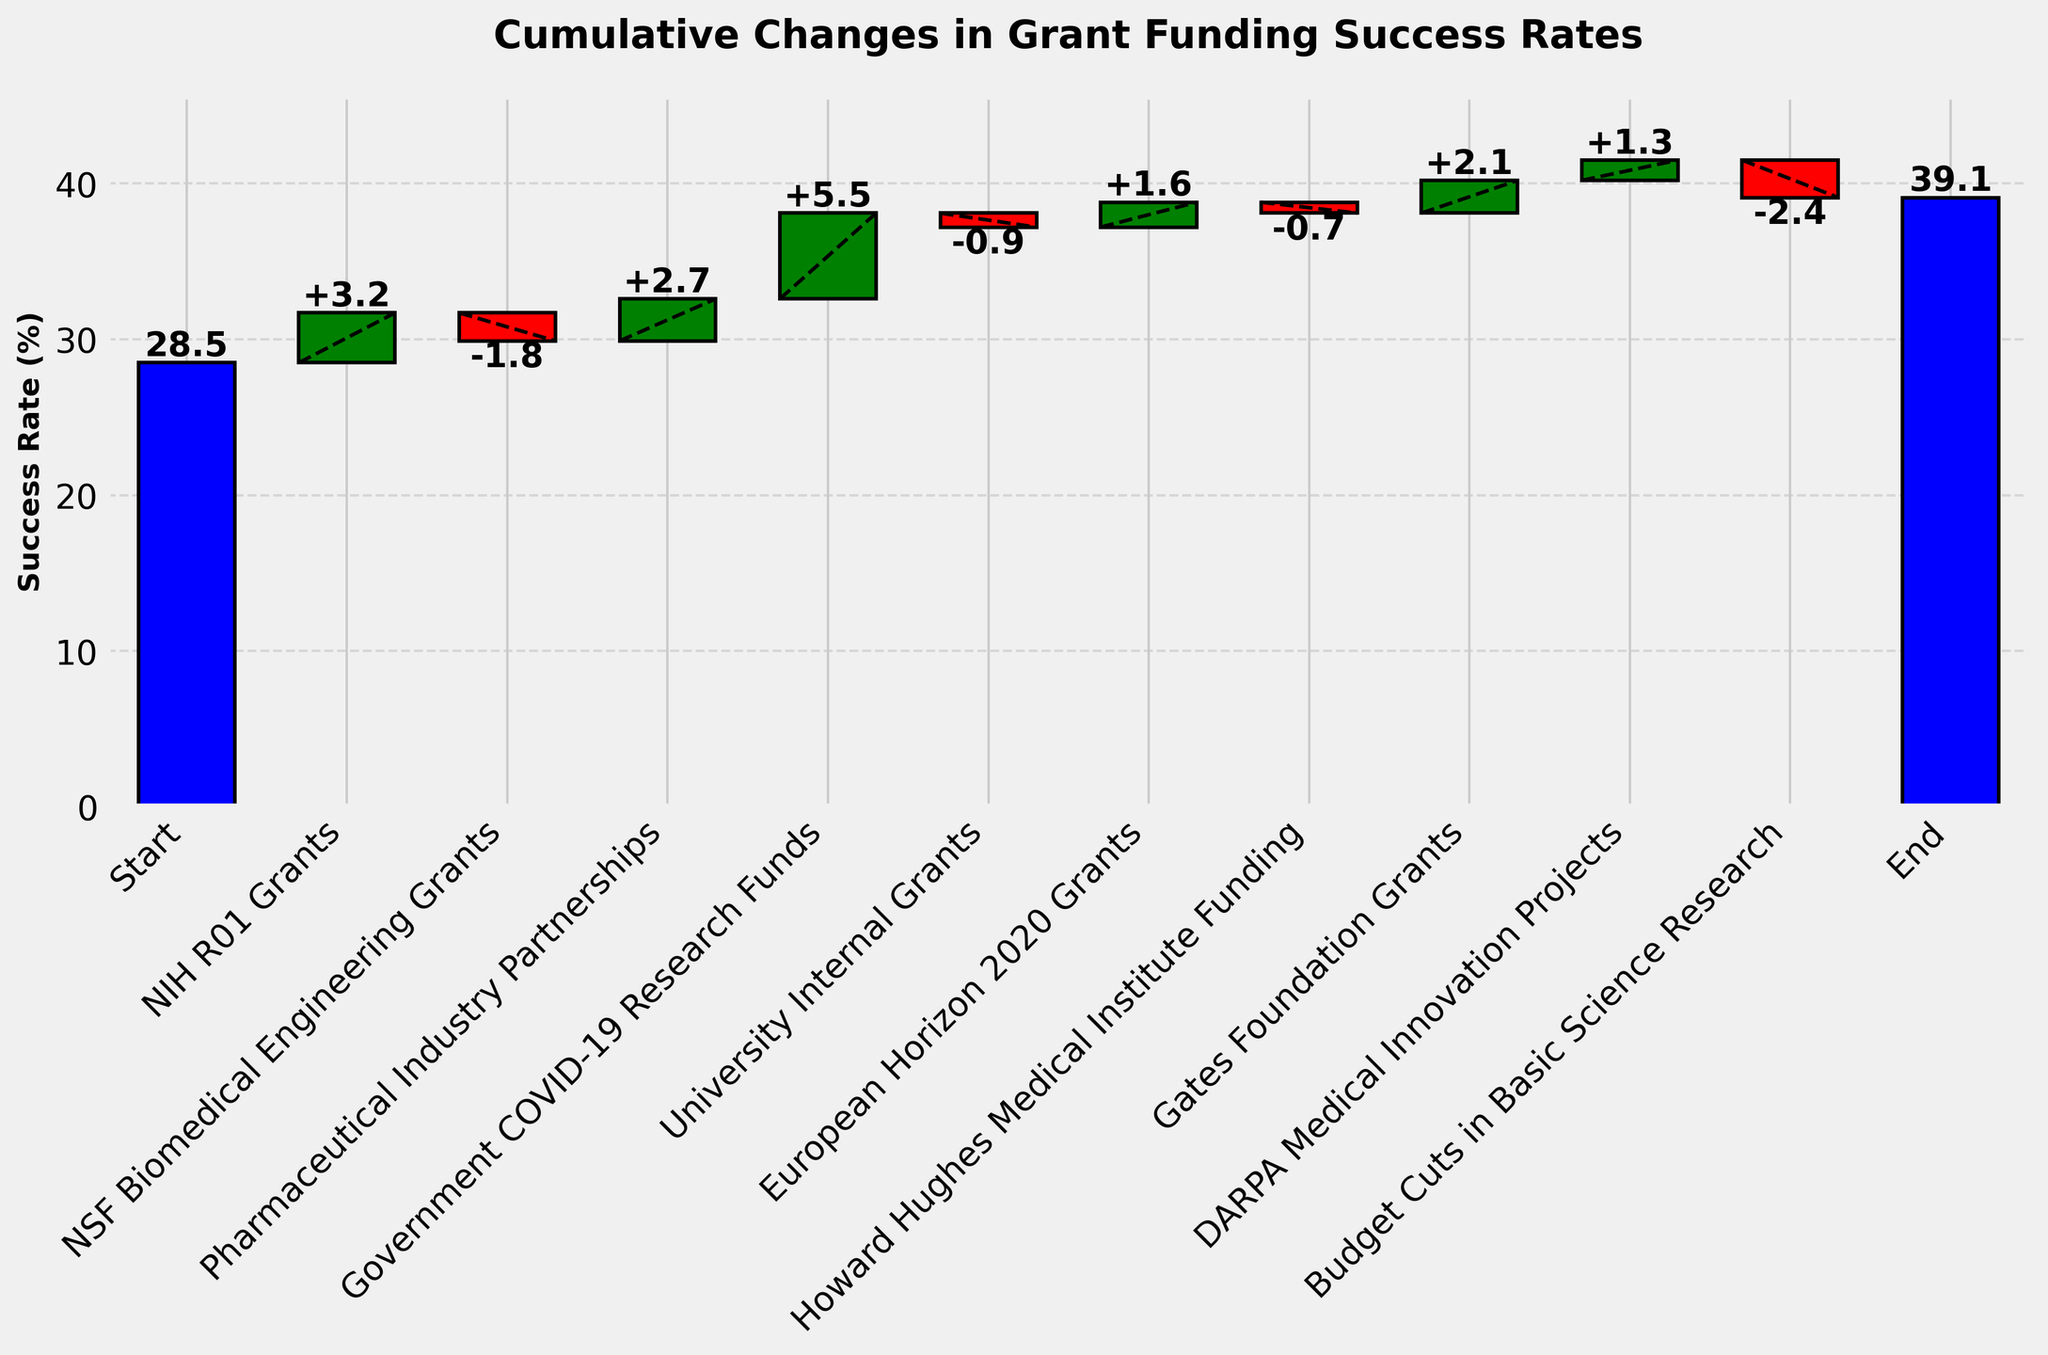what is the title of the chart? The title is usually displayed at the top of the chart. It provides an overview of what the chart is about. In this case, it reads "Cumulative Changes in Grant Funding Success Rates."
Answer: Cumulative Changes in Grant Funding Success Rates what are the starting and final success rates? The starting success rate is the first value represented before any changes are applied, and the final success rate is the last value after all changes are applied. According to the chart, the starting success rate is 28.5%, and the final success rate is 39.1%.
Answer: 28.5% and 39.1% how did NIH R01 grants affect the success rate? The effect of NIH R01 grants is represented by a positive change of +3.2, as shown in the chart. This indicates that they increased the success rate by 3.2 percentage points.
Answer: increased by 3.2% which category contributed the most to the increase in success rate? The category that contributed the most is identified by looking for the largest positive change in the chart. Government COVID-19 Research Funds contributed the most with a +5.5 increase in success rate.
Answer: Government COVID-19 Research Funds how does the reduction from NSF Biomedical Engineering Grants compare to the effect of Budget Cuts in Basic Science Research? To compare these reductions, we look at their respective changes. NSF Biomedical Engineering Grants reduced the success rate by -1.8, while Budget Cuts in Basic Science Research reduced it by -2.4, indicating Budget Cuts in Basic Science Research had a larger negative impact.
Answer: Budget Cuts in Basic Science Research had a larger negative impact what is the cumulative change in success rate before the effect of DARPA Medical Innovation Projects is applied? Calculating the cumulative change involves summing all changes up until DARPA Medical Innovation Projects. Adding: +3.2 - 1.8 + 2.7 + 5.5 - 0.9 + 1.6 - 0.7 + 2.1, results in a cumulative change of +11.7.
Answer: +11.7 which categories had a negative impact on the success rate? Categories with a negative impact have a negative change value in the chart. These are NSF Biomedical Engineering Grants (-1.8), University Internal Grants (-0.9), Howard Hughes Medical Institute Funding (-0.7), and Budget Cuts in Basic Science Research (-2.4).
Answer: NSF Biomedical Engineering Grants, University Internal Grants, Howard Hughes Medical Institute Funding, Budget Cuts in Basic Science Research how many categories increased the success rate? Count the number of categories with positive changes. NIH R01 Grants, Pharmaceutical Industry Partnerships, Government COVID-19 Research Funds, European Horizon 2020 Grants, Gates Foundation Grants, and DARPA Medical Innovation Projects are positive, totaling 6 categories.
Answer: 6 what is the net change in success rate attributed to Howard Hughes Medical Institute Funding and Gates Foundation Grants combined? Combining their changes: Howard Hughes Medical Institute Funding (-0.7) plus Gates Foundation Grants (+2.1) yields a net change of -0.7 + 2.1 = 1.4
Answer: +1.4 which specific contribution shifted the success rate from below 35% to above it? Examine changes until reaching above 35%. Starting at 28.5% with changes +3.2, -1.8, and +2.7, it reaches 32.6%. Adding +5.5 (Government COVID-19 Research Funds) pushes it to 38.1%, above 35%.
Answer: Government COVID-19 Research Funds 